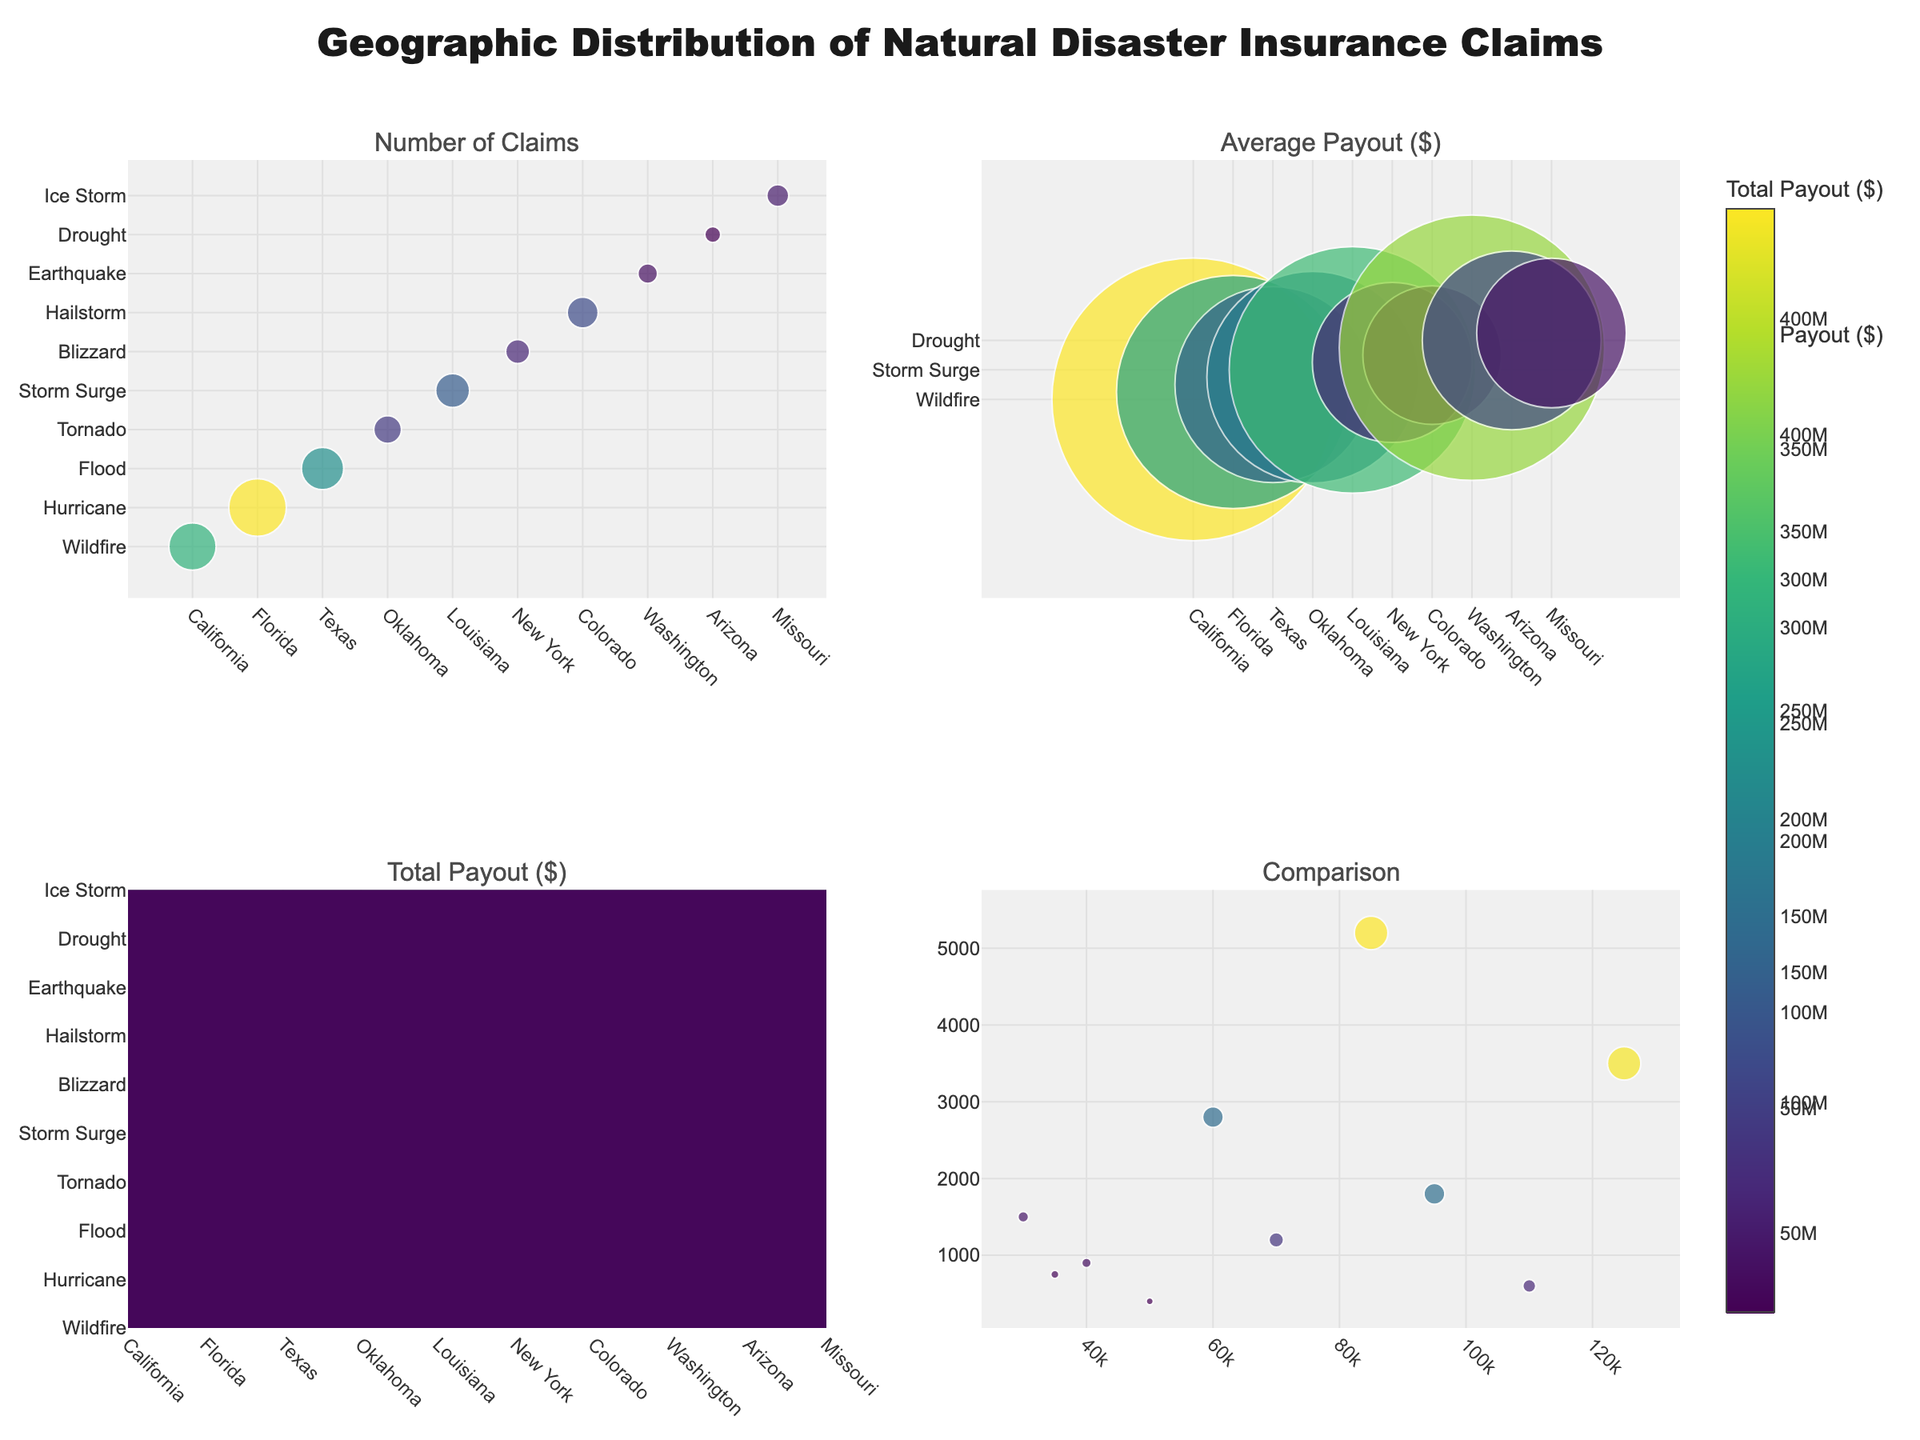How many regions are included in the figure? Count the number of unique regions listed on the x-axes and in the text annotations. There are 10 unique regions.
Answer: 10 What is the disaster type associated with the highest number of claims? Look at the bubble chart for "Number of Claims" and identify the region and disaster with the largest bubble, which is associated with Florida and Hurricanes.
Answer: Hurricane Which region has the smallest average payout amount? In the "Average Payout ($)" subplot, identify the smallest bubble, which is related to Colorado and Hailstorms.
Answer: Colorado Compare the total payout amounts for Texas and Louisiana—who has a higher total payout? Locate Texas and Louisiana in the "Total Payout ($)" subplot. Texas (Flood) has a total payout of $168,000,000, and Louisiana (Storm Surge) has $171,000,000. Thus, Louisiana has a higher total payout.
Answer: Louisiana In the comparison chart, which disaster type had the highest number of claims and the highest average payout amount? Inspect the fourth subplot in the comparison chart, focusing on the disaster type with the largest bubbles. Hurricanes in Florida have the highest combination of these metrics.
Answer: Hurricane Is there any correlation between the number of claims and the average payout amount? In the comparison chart, observe the general trend of how the bubbles are spread. There's no clear trend indicating a strong correlation between these metrics.
Answer: No clear correlation Which disaster type in Oklahoma has a lower average payout than the disaster type in Missouri? Compare the average payout values for Oklahoma (Tornado) and Missouri (Ice Storm). Tornado in Oklahoma has an average payout of $70,000, which is higher than Ice Storm in Missouri at $35,000.
Answer: None What’s the average number of claims across all regions? Sum up all the number of claims and divide by the number of regions. Total claims are 3500 + 5200 + 2800 + 1200 + 1800 + 900 + 1500 + 600 + 400 + 750 = 18,650. Divide by 10 regions: 18,650 / 10 = 1,865.
Answer: 1865 Which region has the highest total payout for an Earthquake? Look at the "Total Payout ($)" subplot and find the region associated with Earthquake. Washington has the highest total payout of $66,000,000 for an Earthquake.
Answer: Washington 